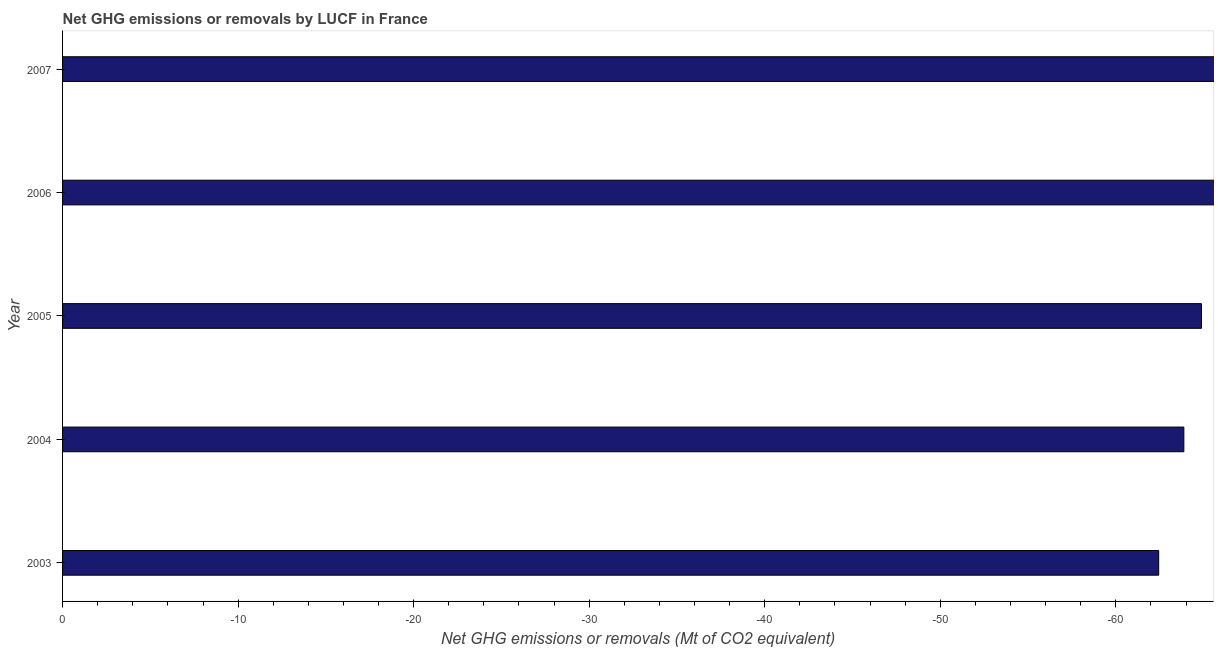Does the graph contain grids?
Offer a very short reply. No. What is the title of the graph?
Your response must be concise. Net GHG emissions or removals by LUCF in France. What is the label or title of the X-axis?
Give a very brief answer. Net GHG emissions or removals (Mt of CO2 equivalent). Across all years, what is the minimum ghg net emissions or removals?
Offer a terse response. 0. What is the sum of the ghg net emissions or removals?
Your answer should be very brief. 0. What is the average ghg net emissions or removals per year?
Your answer should be compact. 0. What is the median ghg net emissions or removals?
Keep it short and to the point. 0. In how many years, is the ghg net emissions or removals greater than -22 Mt?
Offer a very short reply. 0. In how many years, is the ghg net emissions or removals greater than the average ghg net emissions or removals taken over all years?
Ensure brevity in your answer.  0. How many bars are there?
Keep it short and to the point. 0. How many years are there in the graph?
Provide a succinct answer. 5. Are the values on the major ticks of X-axis written in scientific E-notation?
Provide a succinct answer. No. What is the Net GHG emissions or removals (Mt of CO2 equivalent) in 2006?
Your response must be concise. 0. 